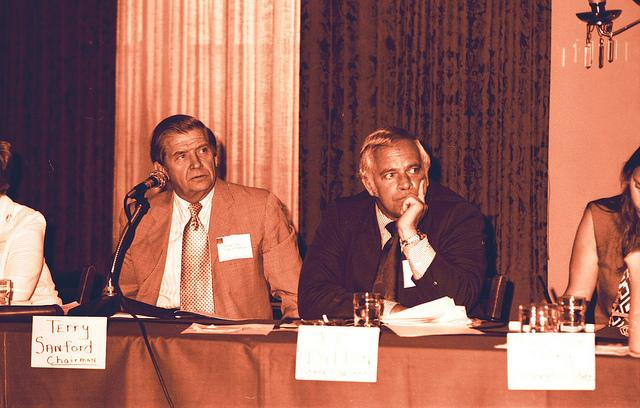What are the men looking at?
Be succinct. Speaker. How many people are here?
Concise answer only. 4. What is the man at the podium doing?
Give a very brief answer. Listening. Is this a modern photo?
Be succinct. No. 